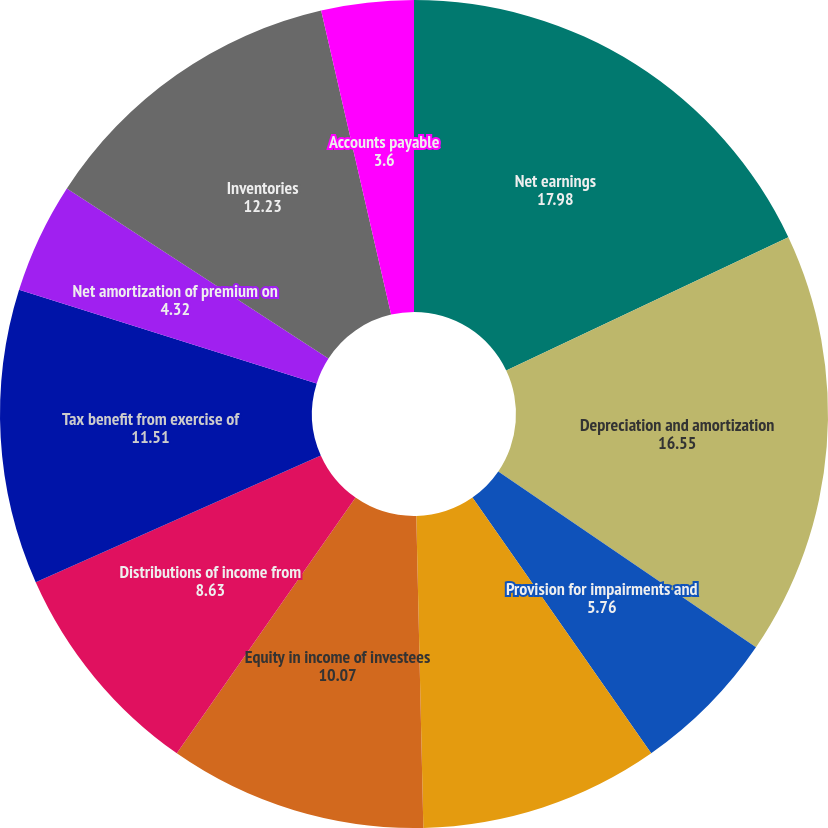Convert chart. <chart><loc_0><loc_0><loc_500><loc_500><pie_chart><fcel>Net earnings<fcel>Depreciation and amortization<fcel>Provision for impairments and<fcel>Deferred income taxes net<fcel>Equity in income of investees<fcel>Distributions of income from<fcel>Tax benefit from exercise of<fcel>Net amortization of premium on<fcel>Inventories<fcel>Accounts payable<nl><fcel>17.98%<fcel>16.55%<fcel>5.76%<fcel>9.35%<fcel>10.07%<fcel>8.63%<fcel>11.51%<fcel>4.32%<fcel>12.23%<fcel>3.6%<nl></chart> 